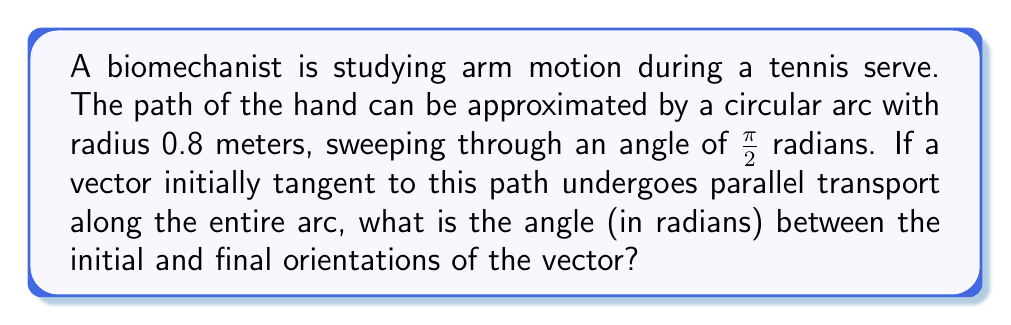Could you help me with this problem? To solve this problem, we need to understand parallel transport on a curved surface and apply it to the given scenario. Let's break it down step-by-step:

1) In Euclidean geometry, parallel transport would result in no change to the vector's orientation. However, on a curved surface (like a sphere), parallel transport leads to a change in orientation relative to the starting point.

2) For a circular path on a sphere, the angle of rotation of a parallel transported vector is related to the solid angle subtended by the path at the center of the sphere.

3) The formula for this angle of rotation $\theta$ is:

   $$\theta = \Omega = 2\pi(1 - \cos(\alpha))$$

   Where $\Omega$ is the solid angle and $\alpha$ is the half-angle of the cone formed by the circular path.

4) In our case, the path sweeps through $\frac{\pi}{2}$ radians, so $\alpha = \frac{\pi}{4}$.

5) Plugging this into our formula:

   $$\theta = 2\pi(1 - \cos(\frac{\pi}{4}))$$

6) We can simplify this:
   $$\theta = 2\pi(1 - \frac{\sqrt{2}}{2})$$
   $$\theta = 2\pi(\frac{2-\sqrt{2}}{2})$$
   $$\theta = \pi(2-\sqrt{2})$$

7) This gives us the angle between the initial and final orientations of the vector after parallel transport.
Answer: $\pi(2-\sqrt{2})$ radians 